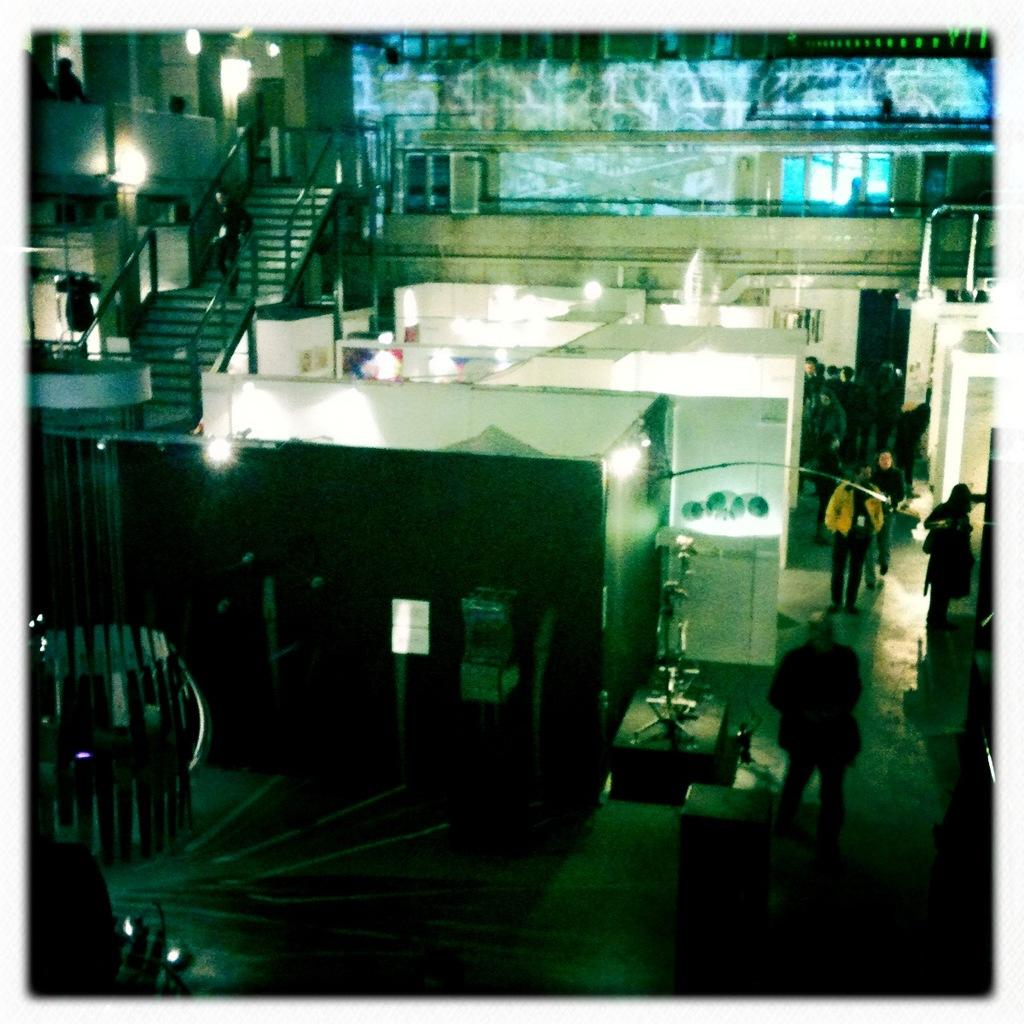What is located on the left side of the image? There are persons, stairs, and lights on the left side of the image. What is the position of the persons on the right side of the image? The persons on the right side are on the floor. What can be seen in the center of the image? There are sheds in the center of the image. What type of fact can be seen written on a note in the image? There is no note or fact present in the image. How many tomatoes are visible on the floor in the image? There are no tomatoes present in the image. 